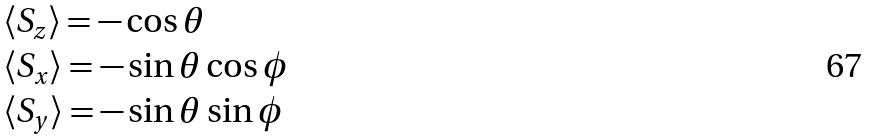<formula> <loc_0><loc_0><loc_500><loc_500>\begin{array} { l } \langle S _ { z } \rangle = - \cos \theta \\ \langle S _ { x } \rangle = - \sin \theta \cos \phi \\ \langle S _ { y } \rangle = - \sin \theta \sin \phi \end{array}</formula> 